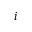<formula> <loc_0><loc_0><loc_500><loc_500>i</formula> 